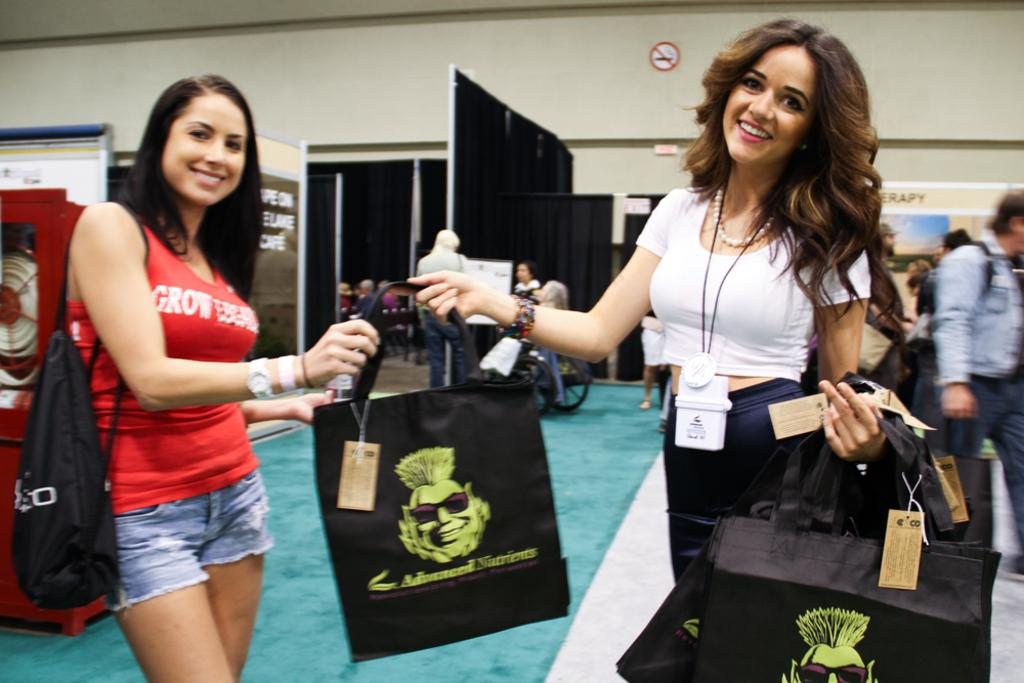How many women are in the image? There are two women in the image. What are the women doing in the image? The women are standing and holding carry bags. What expressions do the women have on their faces? The women have smiles on their faces. Can you describe the people visible in the background of the image? There are more people visible in the background of the image, but their specific actions or appearances cannot be determined from the provided facts. What color is the queen's dress in the image? There is no queen present in the image, so it is not possible to determine the color of her dress. 